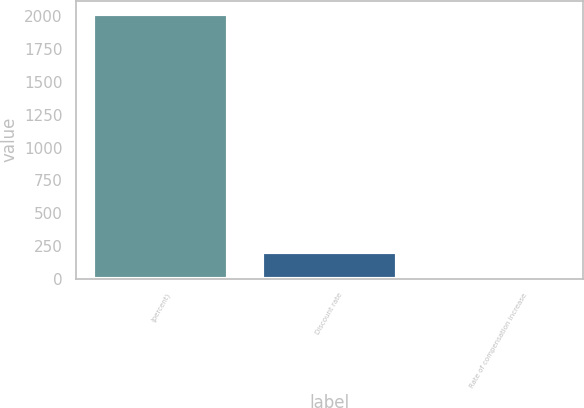Convert chart to OTSL. <chart><loc_0><loc_0><loc_500><loc_500><bar_chart><fcel>(percent)<fcel>Discount rate<fcel>Rate of compensation increase<nl><fcel>2018<fcel>204.49<fcel>2.99<nl></chart> 